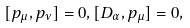<formula> <loc_0><loc_0><loc_500><loc_500>[ p _ { \mu } , p _ { \nu } ] = 0 , [ D _ { \alpha } , p _ { \mu } ] = 0 ,</formula> 